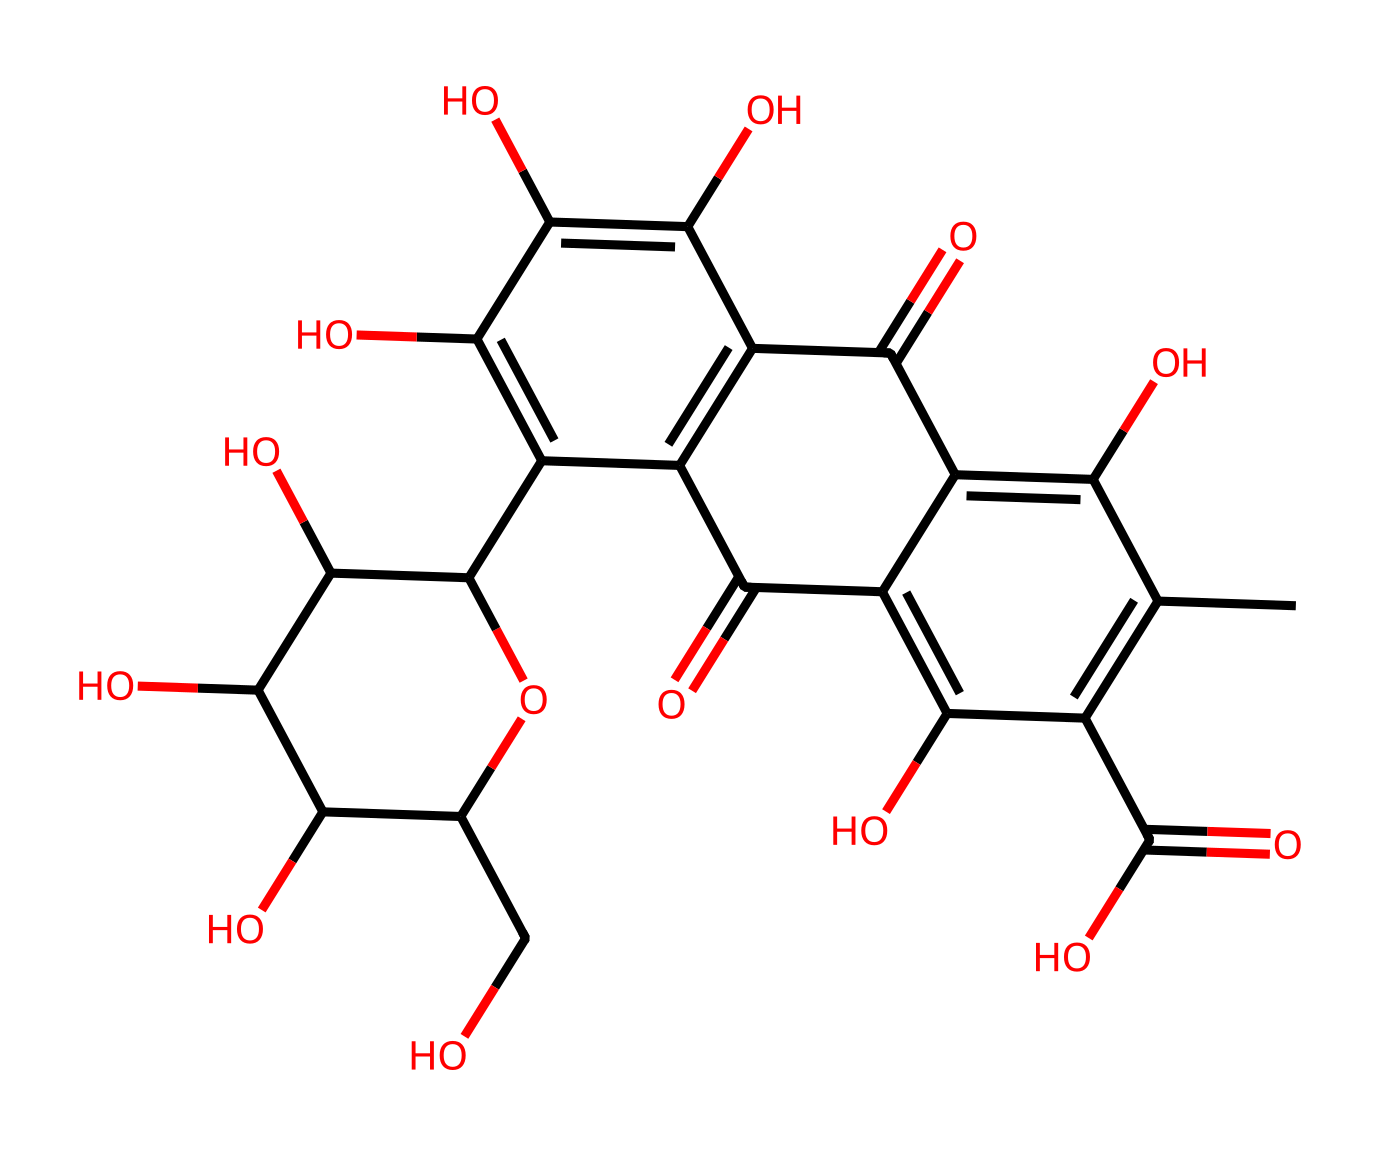What is the name of this dye? The chemical structure corresponds to cochineal dye, derived from the cochineal insect and historically significant in Mesoamerican cultures.
Answer: cochineal dye How many carbon atoms are in the structure? By counting the carbon (C) atoms in the SMILES representation, there are 24 carbon atoms in the structure.
Answer: 24 What functional groups are present in this dye? The structure contains hydroxyl groups (-OH), carbonyl groups (C=O), and aromatic rings, which constitute important functional groups for its properties.
Answer: hydroxyl, carbonyl, aromatic What type of dye is cochineal dye classified as? Cochineal dye is classified as a natural dye because it is derived from a biological source (cochineal insects).
Answer: natural dye Which part of the structure is responsible for its red color? The conjugated system of double bonds and carbonyl groups within the aromatic rings absorbs certain wavelengths of light, imparting the red color characteristic of cochineal dye.
Answer: conjugated system What is the largest ring structure in this chemical? The largest ring structure present in the chemical is a six-membered aromatic ring (a benzene derivative) that contributes to the stability and color of the dye.
Answer: six-membered aromatic ring How many hydroxyl groups are present in cochineal dye? The structure contains 6 hydroxyl groups (each represented by -OH) contributing to its solubility in water and other properties.
Answer: 6 